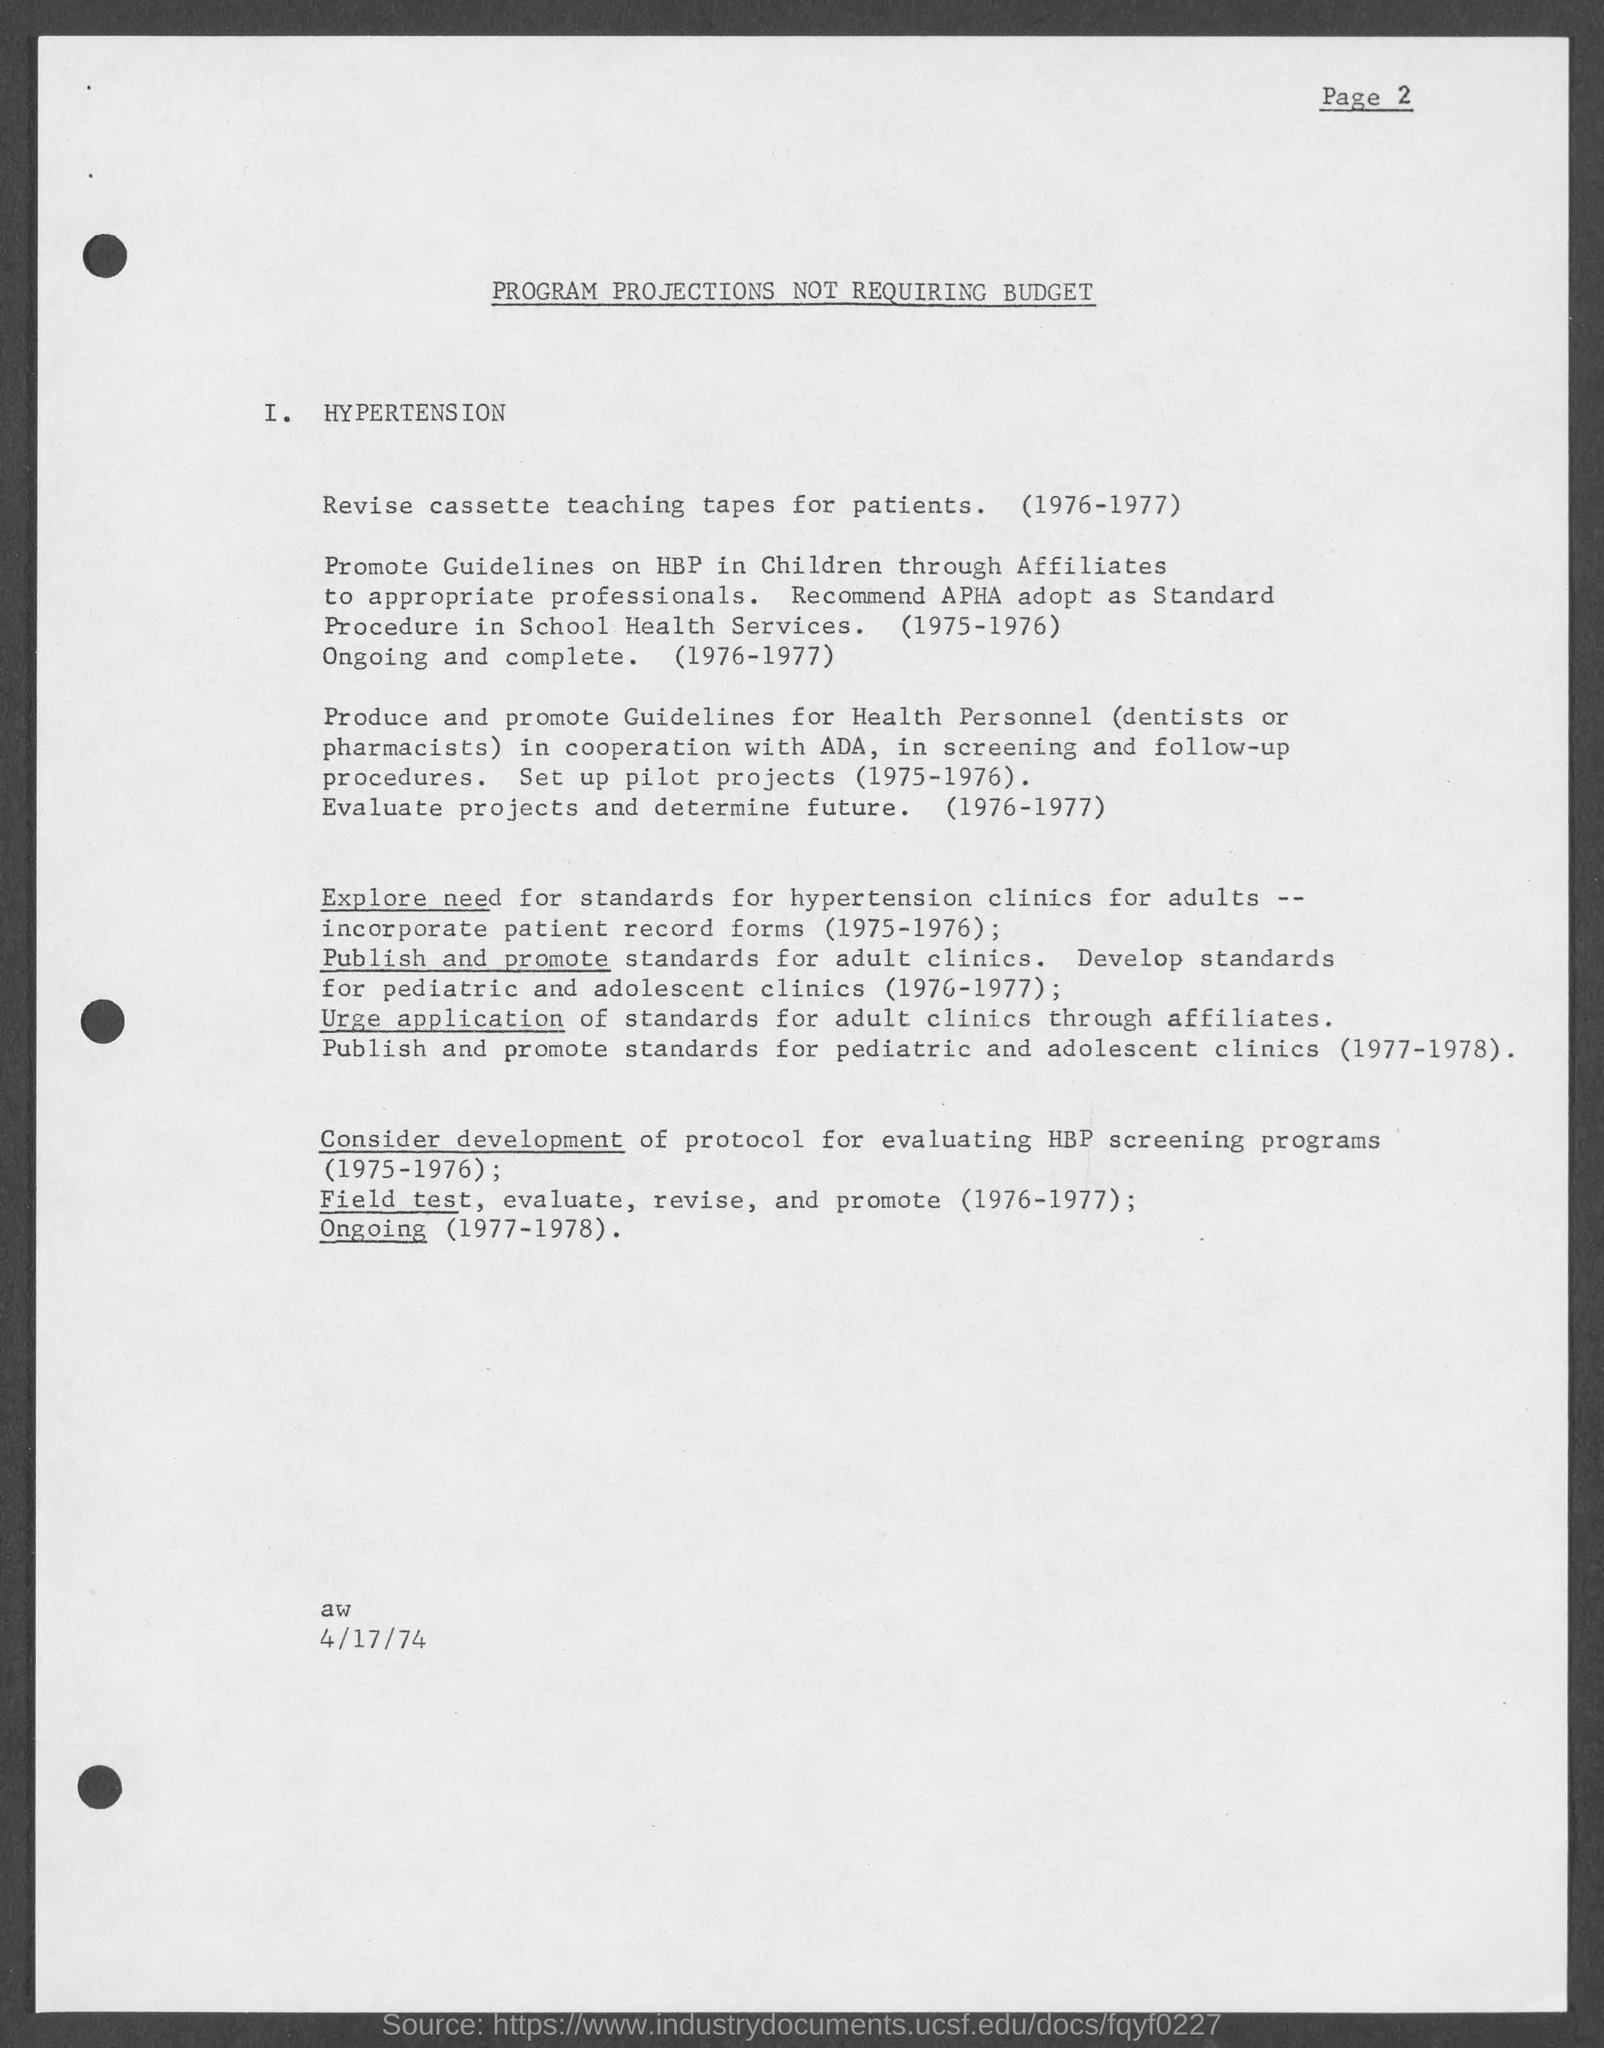What is the date mentioned in this document?
Ensure brevity in your answer.  4/17/74. 